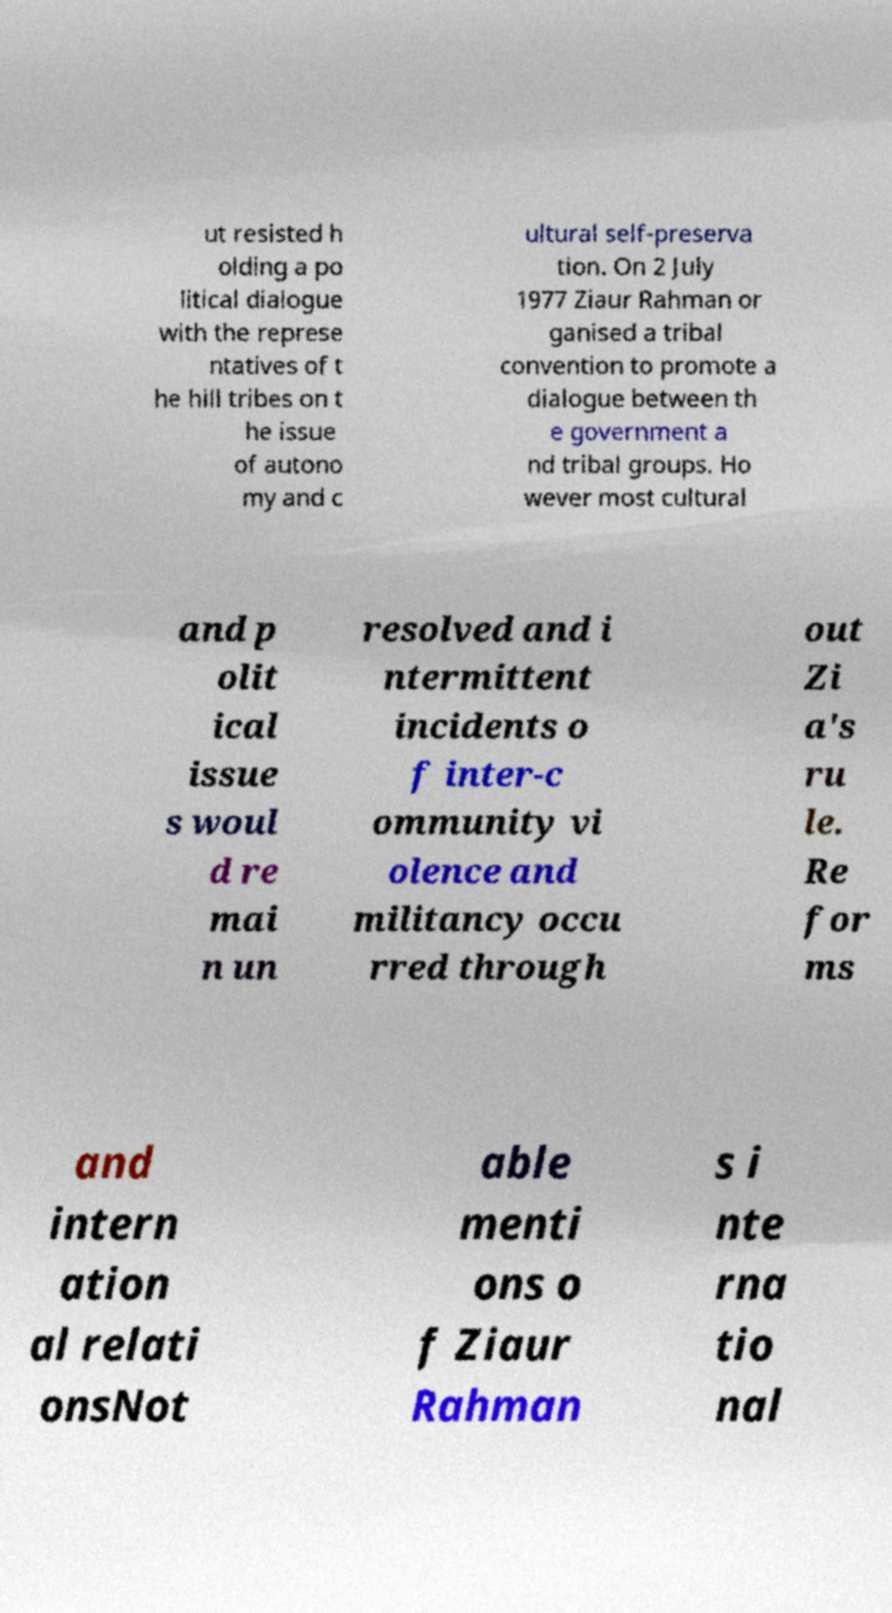What messages or text are displayed in this image? I need them in a readable, typed format. ut resisted h olding a po litical dialogue with the represe ntatives of t he hill tribes on t he issue of autono my and c ultural self-preserva tion. On 2 July 1977 Ziaur Rahman or ganised a tribal convention to promote a dialogue between th e government a nd tribal groups. Ho wever most cultural and p olit ical issue s woul d re mai n un resolved and i ntermittent incidents o f inter-c ommunity vi olence and militancy occu rred through out Zi a's ru le. Re for ms and intern ation al relati onsNot able menti ons o f Ziaur Rahman s i nte rna tio nal 